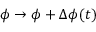<formula> <loc_0><loc_0><loc_500><loc_500>\phi \rightarrow \phi + \Delta \phi ( t )</formula> 